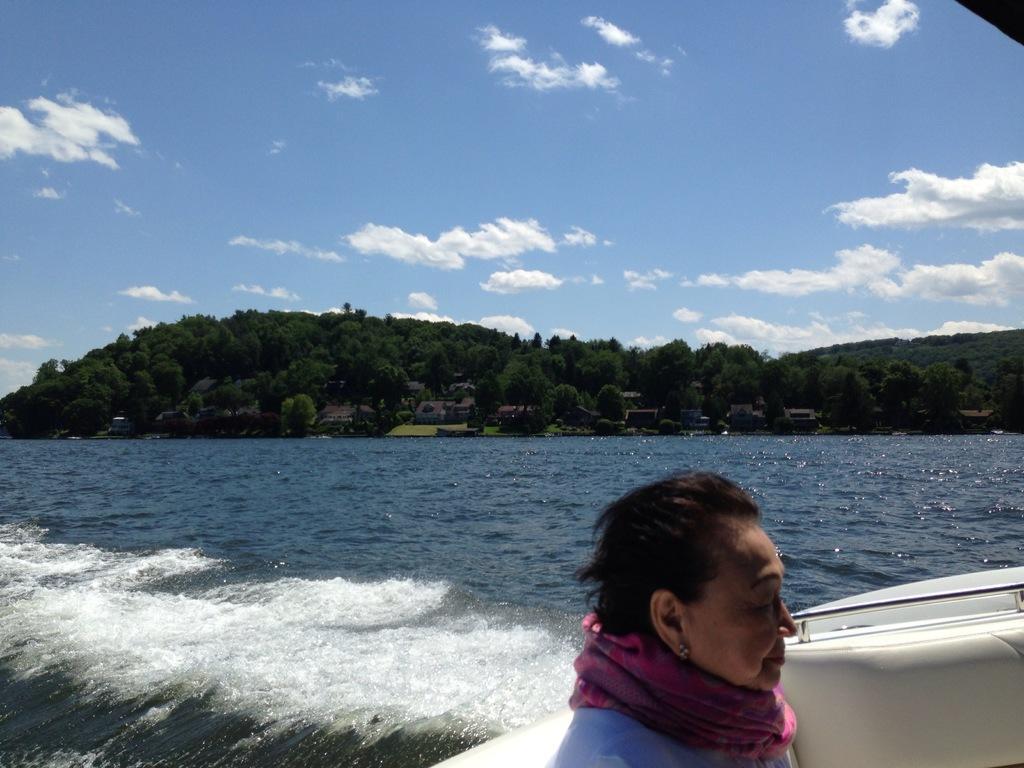Please provide a concise description of this image. In this picture we can see a woman on a boat and this boat is on water and in the background we can see trees, sky with clouds. 